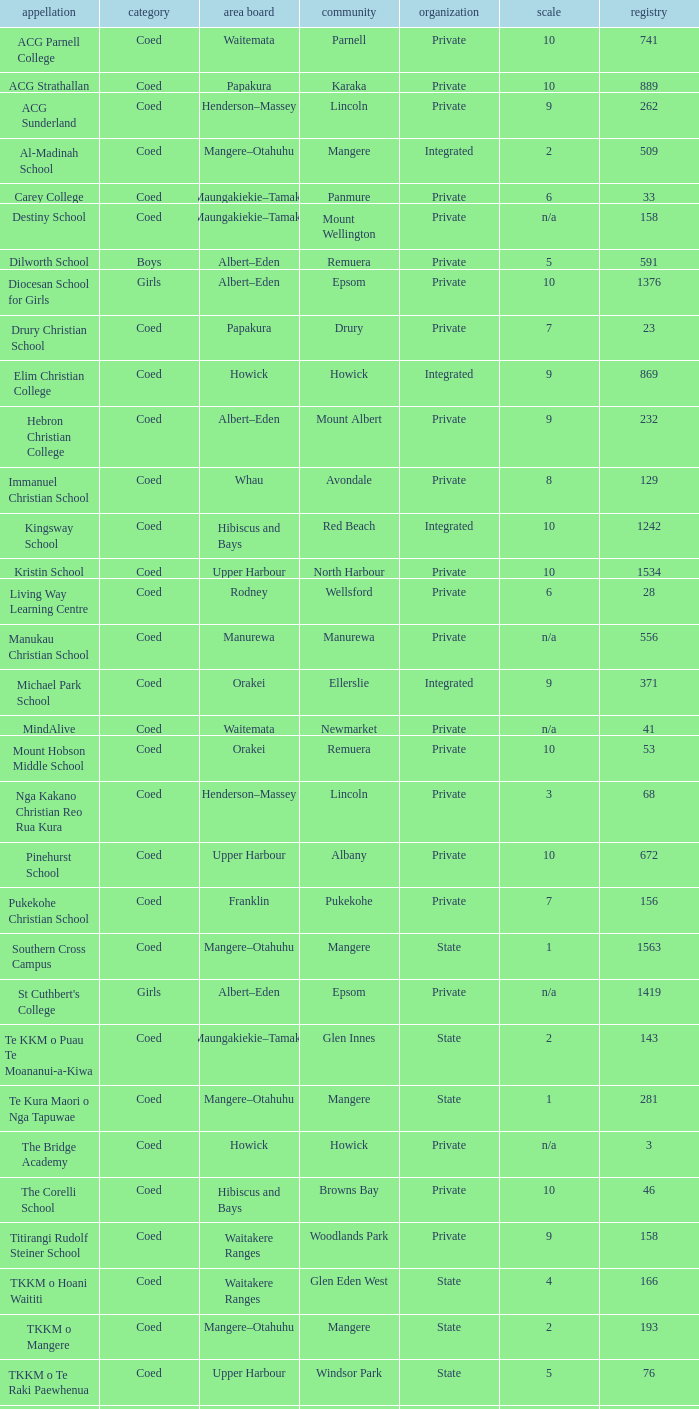What gender has a local board of albert–eden with a roll of more than 232 and Decile of 5? Boys. 